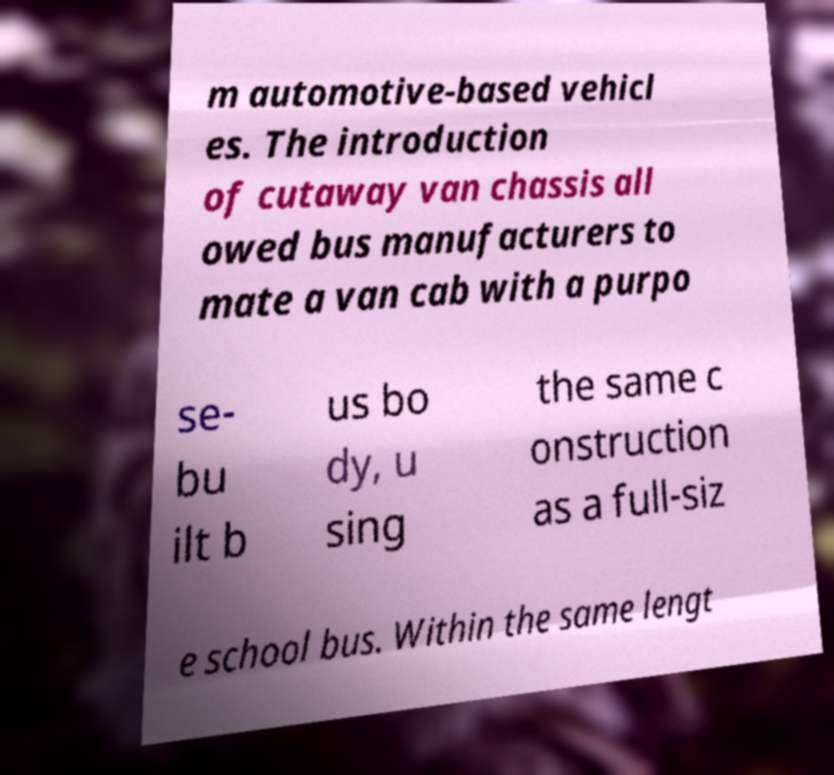There's text embedded in this image that I need extracted. Can you transcribe it verbatim? m automotive-based vehicl es. The introduction of cutaway van chassis all owed bus manufacturers to mate a van cab with a purpo se- bu ilt b us bo dy, u sing the same c onstruction as a full-siz e school bus. Within the same lengt 